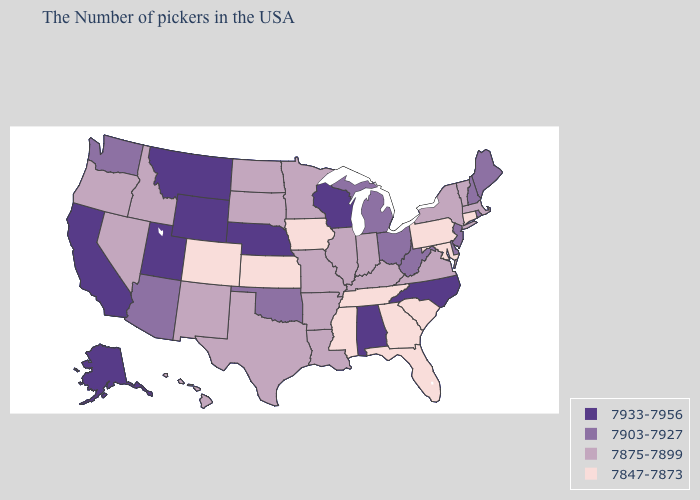Does Montana have the highest value in the USA?
Short answer required. Yes. Among the states that border New York , does Massachusetts have the lowest value?
Be succinct. No. What is the highest value in states that border Wyoming?
Write a very short answer. 7933-7956. What is the value of Missouri?
Concise answer only. 7875-7899. Does North Carolina have a higher value than California?
Concise answer only. No. Which states hav the highest value in the Northeast?
Quick response, please. Maine, Rhode Island, New Hampshire, New Jersey. What is the value of Colorado?
Give a very brief answer. 7847-7873. What is the value of New York?
Keep it brief. 7875-7899. What is the value of North Dakota?
Concise answer only. 7875-7899. Does the map have missing data?
Write a very short answer. No. What is the highest value in the Northeast ?
Quick response, please. 7903-7927. Does Connecticut have the highest value in the Northeast?
Keep it brief. No. Among the states that border South Dakota , does Wyoming have the lowest value?
Be succinct. No. Does New York have the same value as Tennessee?
Write a very short answer. No. 